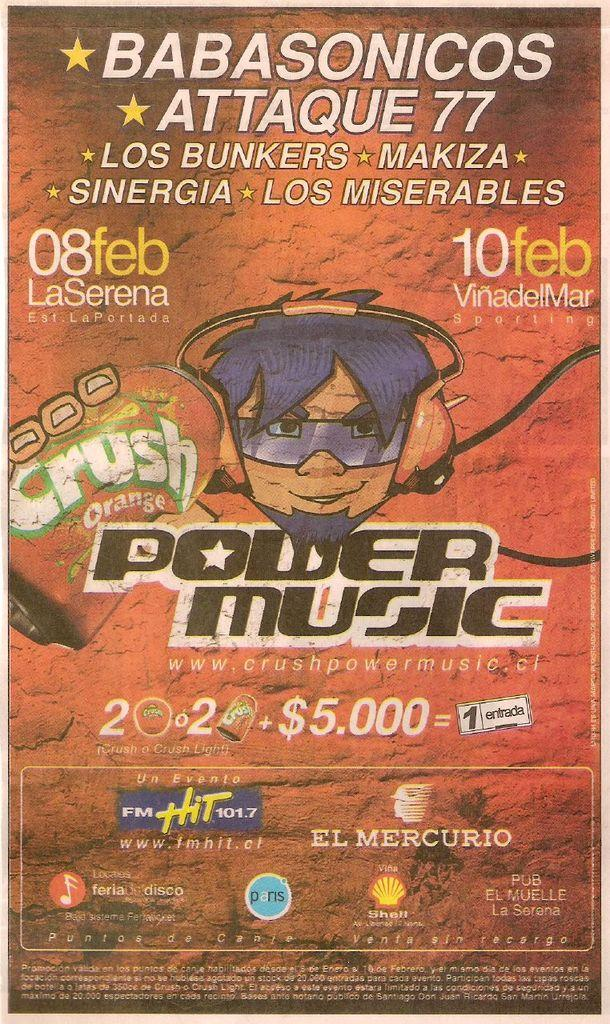Provide a one-sentence caption for the provided image. An advertisement from Power Music is doing something involving Crush orange soda. 